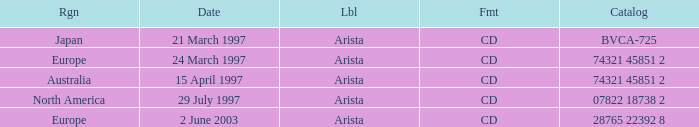Could you parse the entire table? {'header': ['Rgn', 'Date', 'Lbl', 'Fmt', 'Catalog'], 'rows': [['Japan', '21 March 1997', 'Arista', 'CD', 'BVCA-725'], ['Europe', '24 March 1997', 'Arista', 'CD', '74321 45851 2'], ['Australia', '15 April 1997', 'Arista', 'CD', '74321 45851 2'], ['North America', '29 July 1997', 'Arista', 'CD', '07822 18738 2'], ['Europe', '2 June 2003', 'Arista', 'CD', '28765 22392 8']]} What's the Date with the Region of Europe and has a Catalog of 28765 22392 8? 2 June 2003. 